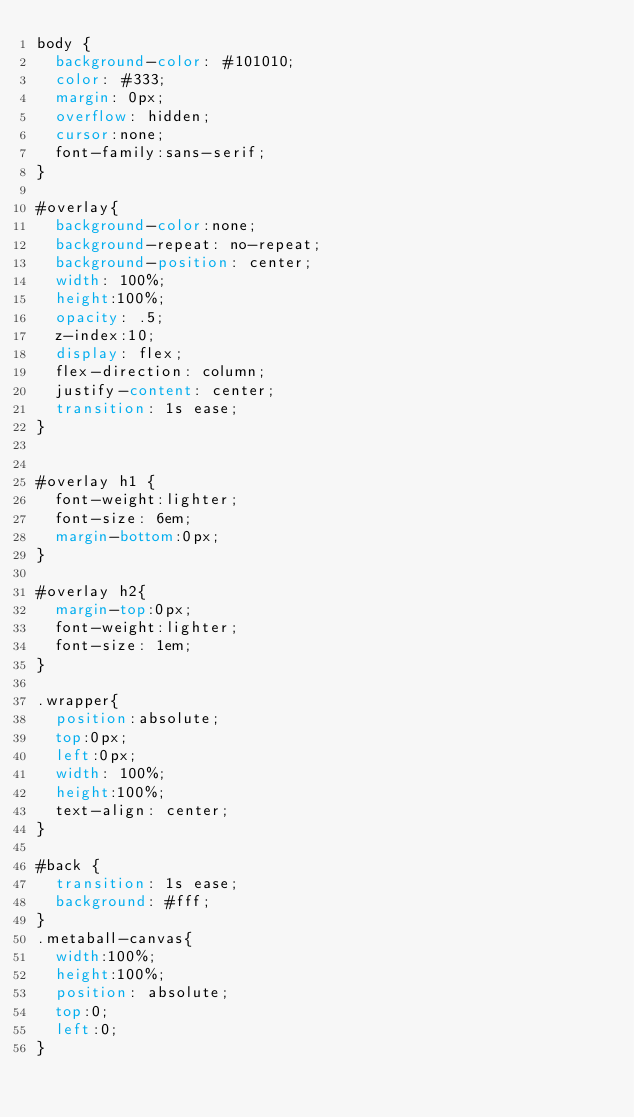<code> <loc_0><loc_0><loc_500><loc_500><_CSS_>body {
  background-color: #101010;
  color: #333;
  margin: 0px;
  overflow: hidden;
  cursor:none;
  font-family:sans-serif;
}

#overlay{
  background-color:none;
  background-repeat: no-repeat;
  background-position: center;
  width: 100%;
  height:100%;
  opacity: .5;
  z-index:10;
  display: flex;
  flex-direction: column;
  justify-content: center;
  transition: 1s ease;
}


#overlay h1 {
  font-weight:lighter;
  font-size: 6em;
  margin-bottom:0px;
}

#overlay h2{
  margin-top:0px;
  font-weight:lighter;
  font-size: 1em;
}

.wrapper{
  position:absolute;
  top:0px;
  left:0px;
  width: 100%;
  height:100%;
  text-align: center;
}

#back {
  transition: 1s ease;
  background: #fff;
}
.metaball-canvas{
  width:100%;
  height:100%;
  position: absolute;
  top:0;
  left:0;
}
</code> 